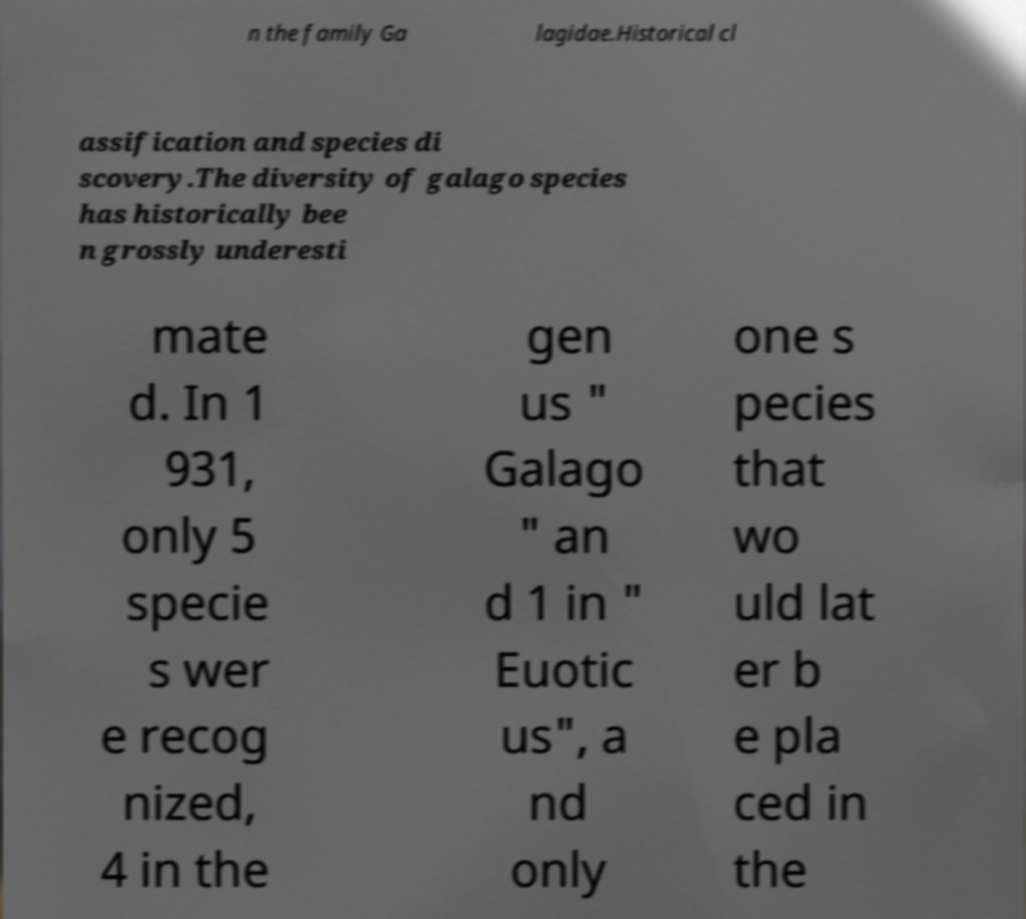Please read and relay the text visible in this image. What does it say? n the family Ga lagidae.Historical cl assification and species di scovery.The diversity of galago species has historically bee n grossly underesti mate d. In 1 931, only 5 specie s wer e recog nized, 4 in the gen us " Galago " an d 1 in " Euotic us", a nd only one s pecies that wo uld lat er b e pla ced in the 